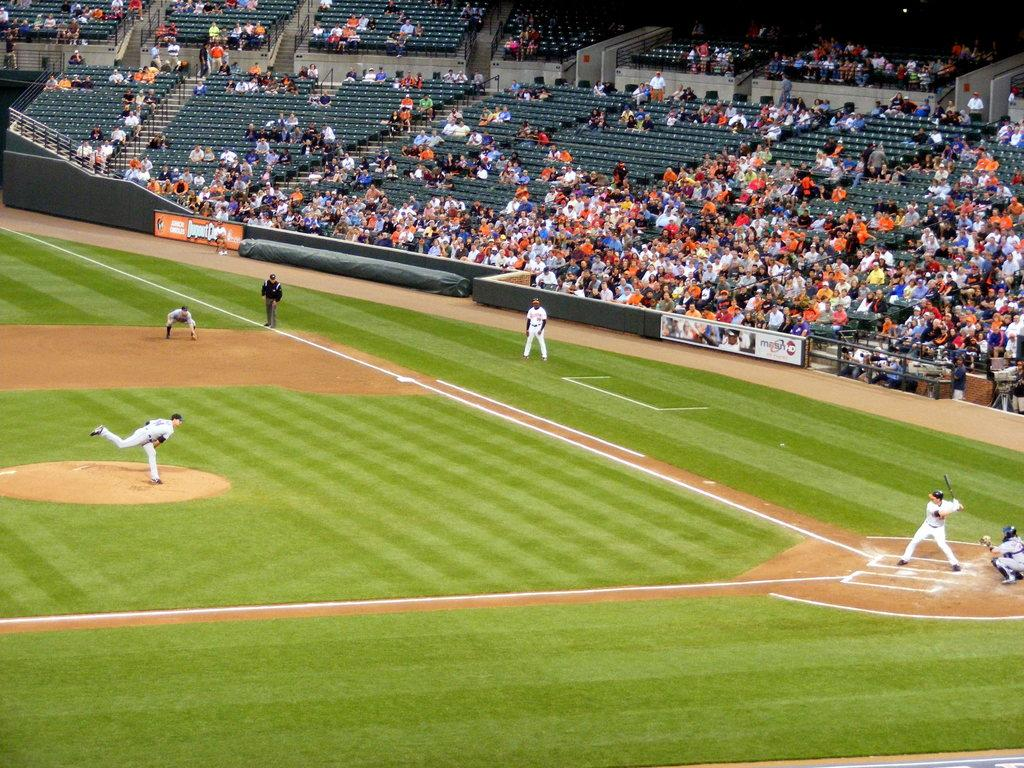What sport are the people playing in the image? The people are playing baseball in the image. What type of surface is the game being played on? There is a grass lawn on the ground. What can be seen in the background of the image? There are many people sitting in a stadium in the background. Are there any additional elements visible in the image? Yes, there are banners visible in the image. What type of thunder can be heard during the game in the image? There is no mention of thunder or any sound in the image, so it cannot be determined from the image. 